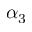Convert formula to latex. <formula><loc_0><loc_0><loc_500><loc_500>\alpha _ { 3 }</formula> 